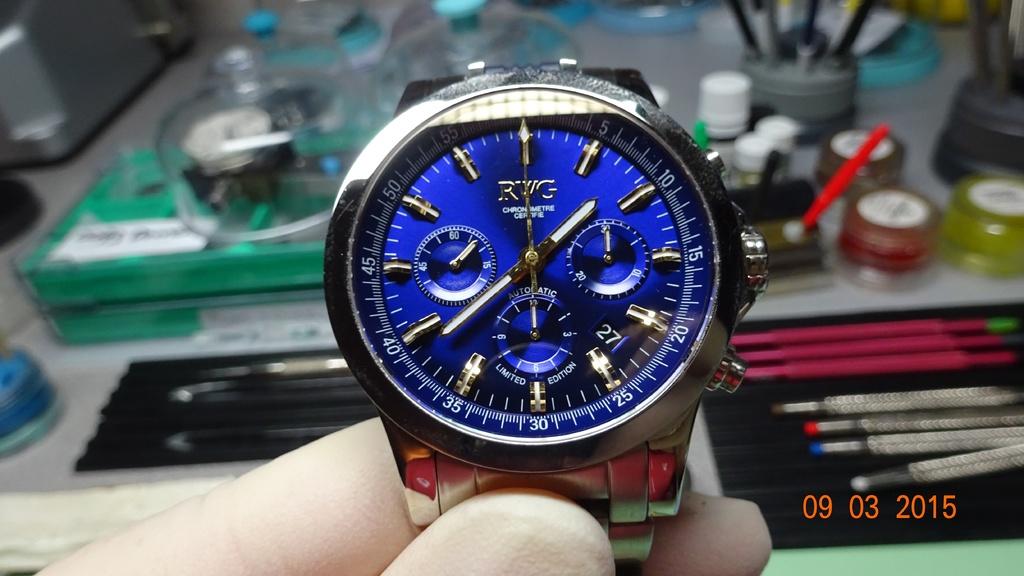What time does the watch show?
Give a very brief answer. 1:38. What date is printed in the bottom right corner?
Keep it short and to the point. 09 03 2015. 